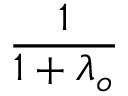Convert formula to latex. <formula><loc_0><loc_0><loc_500><loc_500>\frac { 1 } { 1 + \lambda _ { o } }</formula> 